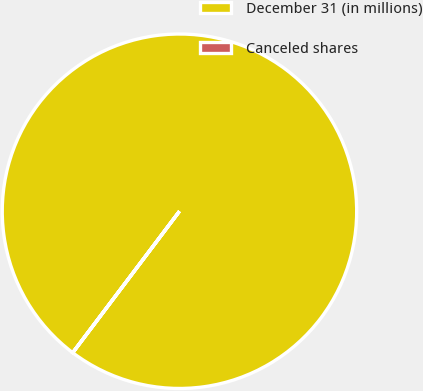<chart> <loc_0><loc_0><loc_500><loc_500><pie_chart><fcel>December 31 (in millions)<fcel>Canceled shares<nl><fcel>99.99%<fcel>0.01%<nl></chart> 